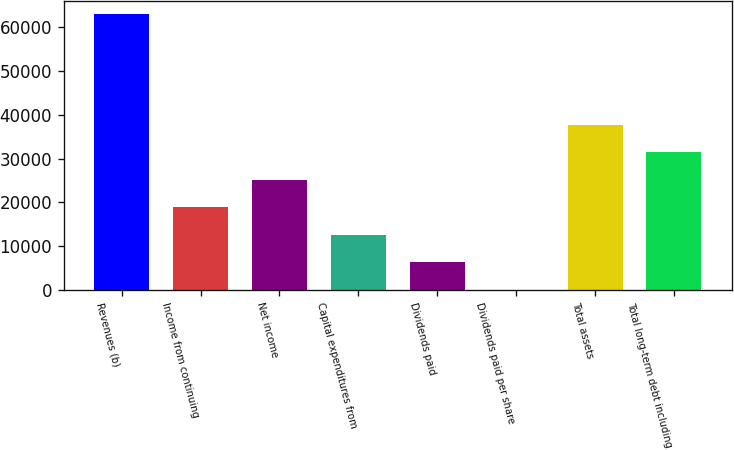<chart> <loc_0><loc_0><loc_500><loc_500><bar_chart><fcel>Revenues (b)<fcel>Income from continuing<fcel>Net income<fcel>Capital expenditures from<fcel>Dividends paid<fcel>Dividends paid per share<fcel>Total assets<fcel>Total long-term debt including<nl><fcel>62986<fcel>18896.7<fcel>25195.1<fcel>12598.2<fcel>6299.7<fcel>1.22<fcel>37792.1<fcel>31493.6<nl></chart> 